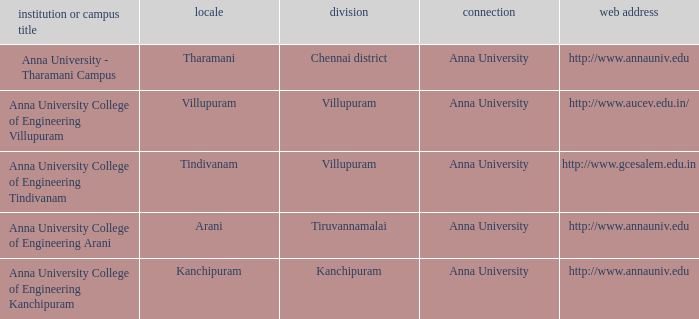What District has a Location of tharamani? Chennai district. 